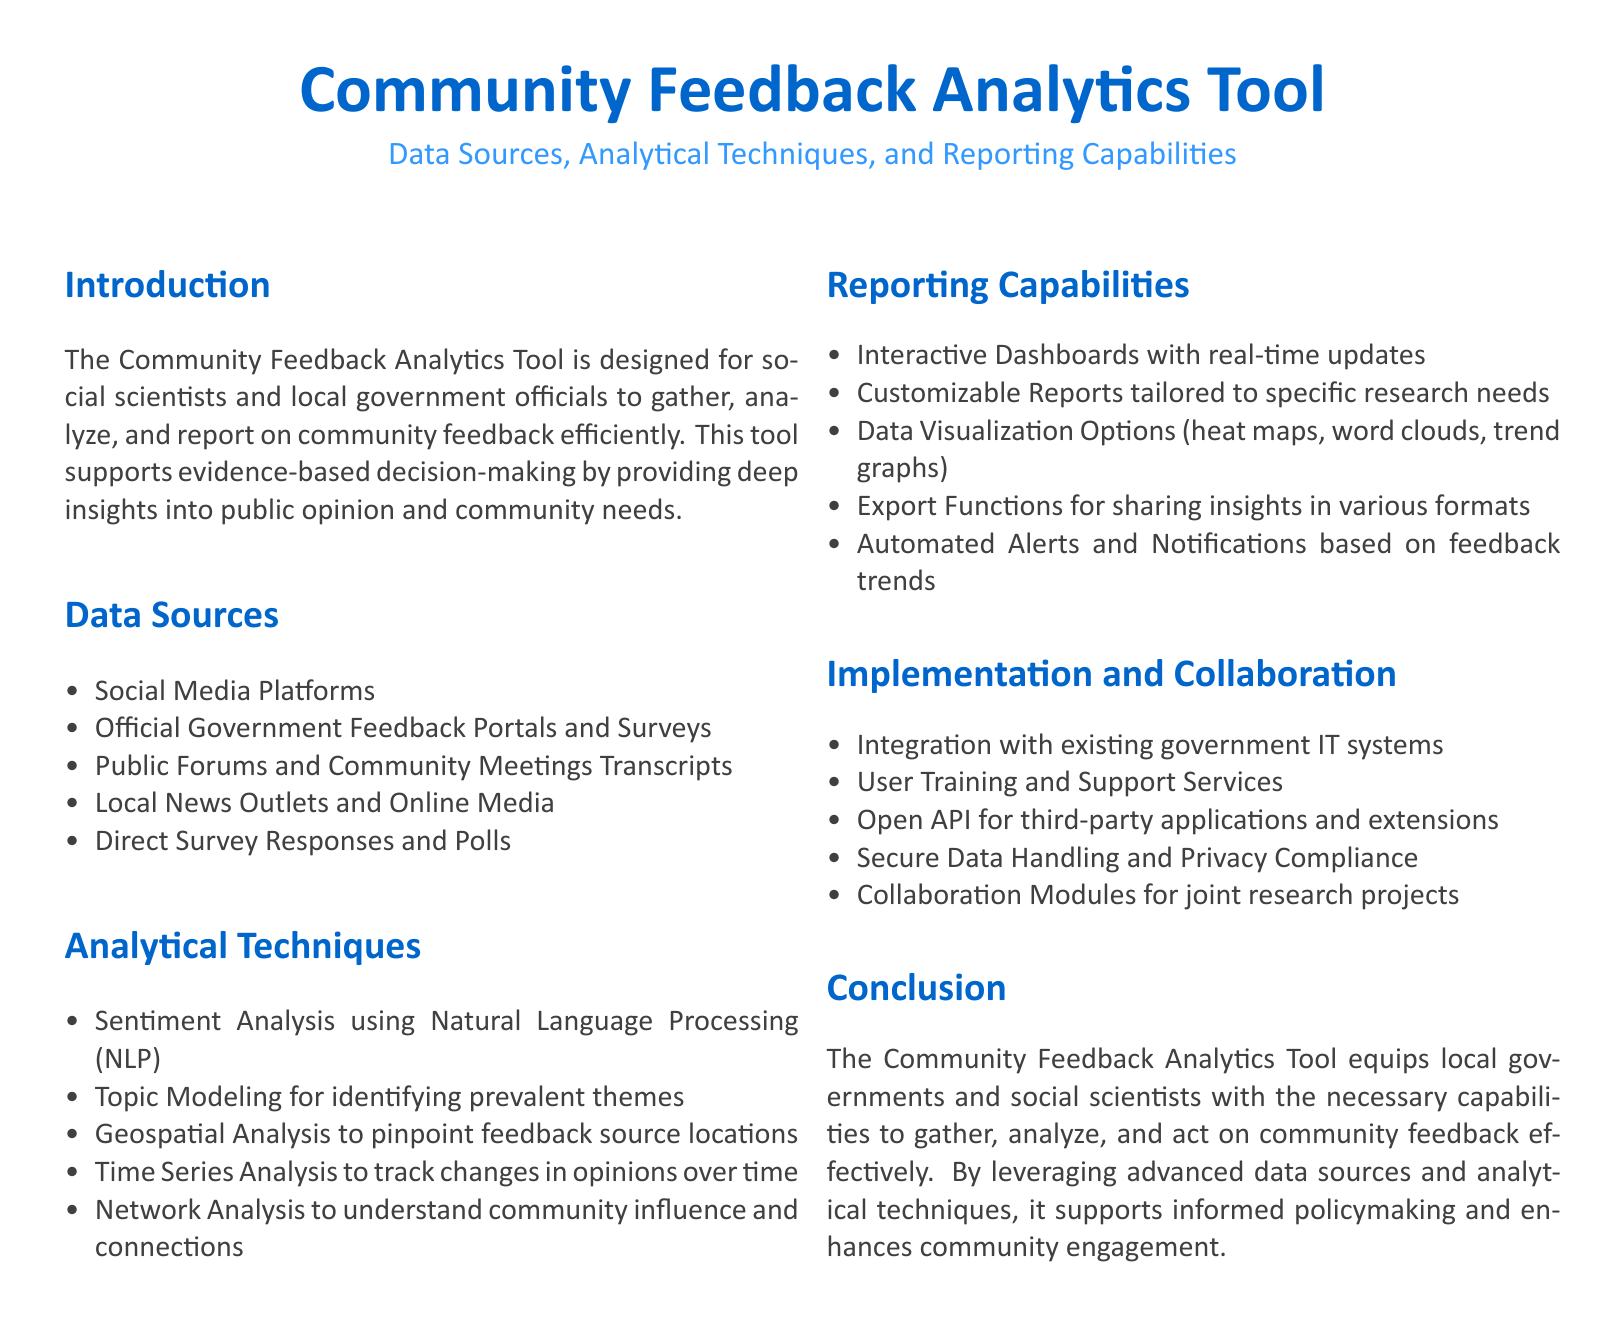What are the main data sources? The main data sources are listed under the "Data Sources" section, which includes various platforms and methods for gathering community feedback.
Answer: Social Media Platforms, Official Government Feedback Portals and Surveys, Public Forums and Community Meetings Transcripts, Local News Outlets and Online Media, Direct Survey Responses and Polls What technique is used for analyzing sentiment? The technique for analyzing sentiment is specified in the "Analytical Techniques" section, highlighting the use of technology.
Answer: Sentiment Analysis using Natural Language Processing How many analytical techniques are mentioned? The number of analytical techniques is determined by counting the listed items in the "Analytical Techniques" section.
Answer: Five What type of reports can be generated? The "Reporting Capabilities" section describes the types of reports that can be created with the tool.
Answer: Customizable Reports tailored to specific research needs What is emphasized in the implementation section? The "Implementation and Collaboration" section emphasizes the strategies for integrating the tool with existing systems and support.
Answer: Integration with existing government IT systems What is one of the main goals of the Community Feedback Analytics Tool? The main goal of the tool is stated in the "Conclusion" section, focusing on its purpose regarding community feedback.
Answer: Gather, analyze, and act on community feedback effectively How does the tool support decision-making? The underlying support for decision-making by the tool is addressed in the introduction, highlighting its role in providing insights.
Answer: Evidence-based decision-making What is a feature of the interactive dashboards? The "Reporting Capabilities" section mentions a specific feature of interactive dashboards that makes them useful.
Answer: Real-time updates 